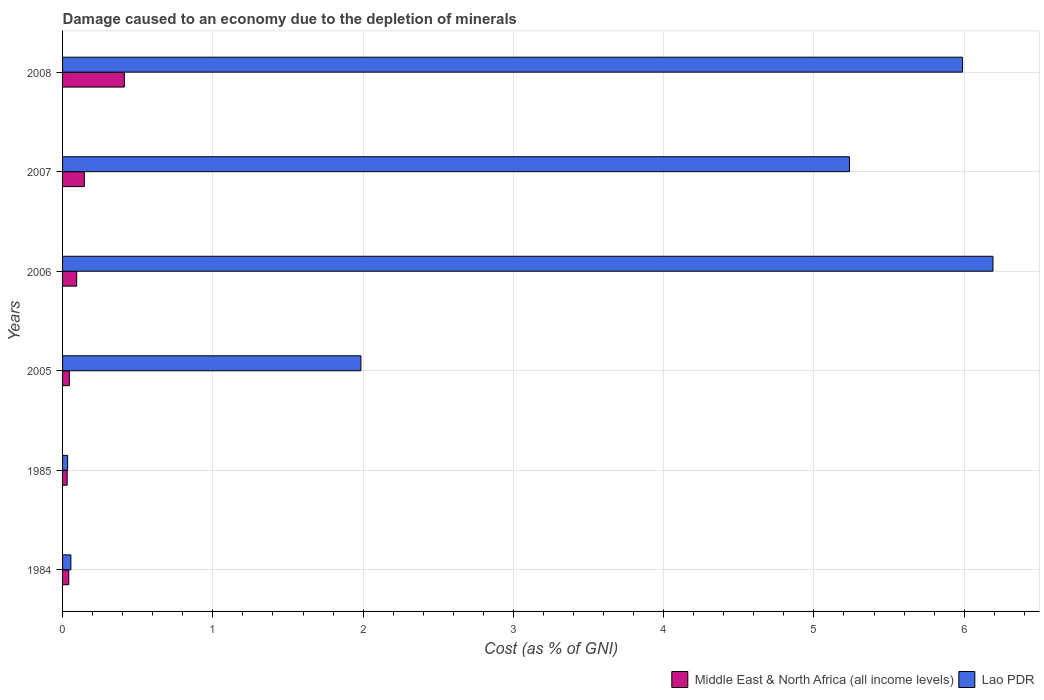What is the label of the 6th group of bars from the top?
Your response must be concise. 1984. What is the cost of damage caused due to the depletion of minerals in Lao PDR in 2006?
Your answer should be very brief. 6.19. Across all years, what is the maximum cost of damage caused due to the depletion of minerals in Middle East & North Africa (all income levels)?
Provide a short and direct response. 0.41. Across all years, what is the minimum cost of damage caused due to the depletion of minerals in Middle East & North Africa (all income levels)?
Your answer should be compact. 0.03. In which year was the cost of damage caused due to the depletion of minerals in Lao PDR maximum?
Ensure brevity in your answer.  2006. What is the total cost of damage caused due to the depletion of minerals in Lao PDR in the graph?
Offer a very short reply. 19.49. What is the difference between the cost of damage caused due to the depletion of minerals in Middle East & North Africa (all income levels) in 2006 and that in 2007?
Keep it short and to the point. -0.05. What is the difference between the cost of damage caused due to the depletion of minerals in Lao PDR in 1985 and the cost of damage caused due to the depletion of minerals in Middle East & North Africa (all income levels) in 2007?
Provide a succinct answer. -0.11. What is the average cost of damage caused due to the depletion of minerals in Middle East & North Africa (all income levels) per year?
Make the answer very short. 0.13. In the year 2005, what is the difference between the cost of damage caused due to the depletion of minerals in Lao PDR and cost of damage caused due to the depletion of minerals in Middle East & North Africa (all income levels)?
Offer a terse response. 1.94. In how many years, is the cost of damage caused due to the depletion of minerals in Lao PDR greater than 4.8 %?
Provide a short and direct response. 3. What is the ratio of the cost of damage caused due to the depletion of minerals in Lao PDR in 2005 to that in 2008?
Give a very brief answer. 0.33. Is the difference between the cost of damage caused due to the depletion of minerals in Lao PDR in 1984 and 2007 greater than the difference between the cost of damage caused due to the depletion of minerals in Middle East & North Africa (all income levels) in 1984 and 2007?
Provide a succinct answer. No. What is the difference between the highest and the second highest cost of damage caused due to the depletion of minerals in Lao PDR?
Ensure brevity in your answer.  0.2. What is the difference between the highest and the lowest cost of damage caused due to the depletion of minerals in Lao PDR?
Keep it short and to the point. 6.16. In how many years, is the cost of damage caused due to the depletion of minerals in Middle East & North Africa (all income levels) greater than the average cost of damage caused due to the depletion of minerals in Middle East & North Africa (all income levels) taken over all years?
Offer a terse response. 2. What does the 1st bar from the top in 2007 represents?
Ensure brevity in your answer.  Lao PDR. What does the 2nd bar from the bottom in 1984 represents?
Make the answer very short. Lao PDR. How many bars are there?
Offer a very short reply. 12. Does the graph contain any zero values?
Offer a very short reply. No. Does the graph contain grids?
Make the answer very short. Yes. Where does the legend appear in the graph?
Ensure brevity in your answer.  Bottom right. How are the legend labels stacked?
Make the answer very short. Horizontal. What is the title of the graph?
Ensure brevity in your answer.  Damage caused to an economy due to the depletion of minerals. What is the label or title of the X-axis?
Offer a terse response. Cost (as % of GNI). What is the Cost (as % of GNI) of Middle East & North Africa (all income levels) in 1984?
Keep it short and to the point. 0.04. What is the Cost (as % of GNI) of Lao PDR in 1984?
Make the answer very short. 0.06. What is the Cost (as % of GNI) of Middle East & North Africa (all income levels) in 1985?
Ensure brevity in your answer.  0.03. What is the Cost (as % of GNI) in Lao PDR in 1985?
Make the answer very short. 0.03. What is the Cost (as % of GNI) in Middle East & North Africa (all income levels) in 2005?
Your answer should be very brief. 0.05. What is the Cost (as % of GNI) of Lao PDR in 2005?
Your answer should be compact. 1.99. What is the Cost (as % of GNI) of Middle East & North Africa (all income levels) in 2006?
Ensure brevity in your answer.  0.09. What is the Cost (as % of GNI) of Lao PDR in 2006?
Provide a short and direct response. 6.19. What is the Cost (as % of GNI) in Middle East & North Africa (all income levels) in 2007?
Your response must be concise. 0.14. What is the Cost (as % of GNI) in Lao PDR in 2007?
Offer a very short reply. 5.24. What is the Cost (as % of GNI) in Middle East & North Africa (all income levels) in 2008?
Your answer should be compact. 0.41. What is the Cost (as % of GNI) of Lao PDR in 2008?
Provide a short and direct response. 5.99. Across all years, what is the maximum Cost (as % of GNI) in Middle East & North Africa (all income levels)?
Your answer should be very brief. 0.41. Across all years, what is the maximum Cost (as % of GNI) in Lao PDR?
Offer a very short reply. 6.19. Across all years, what is the minimum Cost (as % of GNI) of Middle East & North Africa (all income levels)?
Your response must be concise. 0.03. Across all years, what is the minimum Cost (as % of GNI) in Lao PDR?
Your response must be concise. 0.03. What is the total Cost (as % of GNI) in Middle East & North Africa (all income levels) in the graph?
Provide a succinct answer. 0.77. What is the total Cost (as % of GNI) in Lao PDR in the graph?
Give a very brief answer. 19.49. What is the difference between the Cost (as % of GNI) in Middle East & North Africa (all income levels) in 1984 and that in 1985?
Provide a succinct answer. 0.01. What is the difference between the Cost (as % of GNI) of Lao PDR in 1984 and that in 1985?
Provide a succinct answer. 0.02. What is the difference between the Cost (as % of GNI) of Middle East & North Africa (all income levels) in 1984 and that in 2005?
Offer a very short reply. -0. What is the difference between the Cost (as % of GNI) in Lao PDR in 1984 and that in 2005?
Provide a succinct answer. -1.93. What is the difference between the Cost (as % of GNI) of Middle East & North Africa (all income levels) in 1984 and that in 2006?
Keep it short and to the point. -0.05. What is the difference between the Cost (as % of GNI) in Lao PDR in 1984 and that in 2006?
Your answer should be very brief. -6.14. What is the difference between the Cost (as % of GNI) of Middle East & North Africa (all income levels) in 1984 and that in 2007?
Offer a very short reply. -0.1. What is the difference between the Cost (as % of GNI) in Lao PDR in 1984 and that in 2007?
Ensure brevity in your answer.  -5.18. What is the difference between the Cost (as % of GNI) of Middle East & North Africa (all income levels) in 1984 and that in 2008?
Provide a short and direct response. -0.37. What is the difference between the Cost (as % of GNI) in Lao PDR in 1984 and that in 2008?
Provide a short and direct response. -5.93. What is the difference between the Cost (as % of GNI) in Middle East & North Africa (all income levels) in 1985 and that in 2005?
Offer a terse response. -0.01. What is the difference between the Cost (as % of GNI) in Lao PDR in 1985 and that in 2005?
Offer a terse response. -1.95. What is the difference between the Cost (as % of GNI) of Middle East & North Africa (all income levels) in 1985 and that in 2006?
Provide a succinct answer. -0.06. What is the difference between the Cost (as % of GNI) of Lao PDR in 1985 and that in 2006?
Provide a short and direct response. -6.16. What is the difference between the Cost (as % of GNI) of Middle East & North Africa (all income levels) in 1985 and that in 2007?
Provide a succinct answer. -0.11. What is the difference between the Cost (as % of GNI) in Lao PDR in 1985 and that in 2007?
Ensure brevity in your answer.  -5.2. What is the difference between the Cost (as % of GNI) of Middle East & North Africa (all income levels) in 1985 and that in 2008?
Ensure brevity in your answer.  -0.38. What is the difference between the Cost (as % of GNI) in Lao PDR in 1985 and that in 2008?
Offer a very short reply. -5.96. What is the difference between the Cost (as % of GNI) of Middle East & North Africa (all income levels) in 2005 and that in 2006?
Offer a terse response. -0.05. What is the difference between the Cost (as % of GNI) in Lao PDR in 2005 and that in 2006?
Your answer should be very brief. -4.21. What is the difference between the Cost (as % of GNI) in Middle East & North Africa (all income levels) in 2005 and that in 2007?
Ensure brevity in your answer.  -0.1. What is the difference between the Cost (as % of GNI) of Lao PDR in 2005 and that in 2007?
Offer a terse response. -3.25. What is the difference between the Cost (as % of GNI) of Middle East & North Africa (all income levels) in 2005 and that in 2008?
Offer a terse response. -0.37. What is the difference between the Cost (as % of GNI) in Lao PDR in 2005 and that in 2008?
Provide a short and direct response. -4. What is the difference between the Cost (as % of GNI) in Middle East & North Africa (all income levels) in 2006 and that in 2007?
Your answer should be very brief. -0.05. What is the difference between the Cost (as % of GNI) of Lao PDR in 2006 and that in 2007?
Offer a very short reply. 0.95. What is the difference between the Cost (as % of GNI) in Middle East & North Africa (all income levels) in 2006 and that in 2008?
Offer a very short reply. -0.32. What is the difference between the Cost (as % of GNI) of Lao PDR in 2006 and that in 2008?
Ensure brevity in your answer.  0.2. What is the difference between the Cost (as % of GNI) of Middle East & North Africa (all income levels) in 2007 and that in 2008?
Your response must be concise. -0.27. What is the difference between the Cost (as % of GNI) in Lao PDR in 2007 and that in 2008?
Keep it short and to the point. -0.75. What is the difference between the Cost (as % of GNI) in Middle East & North Africa (all income levels) in 1984 and the Cost (as % of GNI) in Lao PDR in 1985?
Your answer should be very brief. 0.01. What is the difference between the Cost (as % of GNI) of Middle East & North Africa (all income levels) in 1984 and the Cost (as % of GNI) of Lao PDR in 2005?
Offer a very short reply. -1.94. What is the difference between the Cost (as % of GNI) of Middle East & North Africa (all income levels) in 1984 and the Cost (as % of GNI) of Lao PDR in 2006?
Your response must be concise. -6.15. What is the difference between the Cost (as % of GNI) in Middle East & North Africa (all income levels) in 1984 and the Cost (as % of GNI) in Lao PDR in 2007?
Your answer should be compact. -5.2. What is the difference between the Cost (as % of GNI) in Middle East & North Africa (all income levels) in 1984 and the Cost (as % of GNI) in Lao PDR in 2008?
Your answer should be compact. -5.95. What is the difference between the Cost (as % of GNI) of Middle East & North Africa (all income levels) in 1985 and the Cost (as % of GNI) of Lao PDR in 2005?
Provide a succinct answer. -1.95. What is the difference between the Cost (as % of GNI) in Middle East & North Africa (all income levels) in 1985 and the Cost (as % of GNI) in Lao PDR in 2006?
Make the answer very short. -6.16. What is the difference between the Cost (as % of GNI) in Middle East & North Africa (all income levels) in 1985 and the Cost (as % of GNI) in Lao PDR in 2007?
Your response must be concise. -5.21. What is the difference between the Cost (as % of GNI) in Middle East & North Africa (all income levels) in 1985 and the Cost (as % of GNI) in Lao PDR in 2008?
Your response must be concise. -5.96. What is the difference between the Cost (as % of GNI) in Middle East & North Africa (all income levels) in 2005 and the Cost (as % of GNI) in Lao PDR in 2006?
Make the answer very short. -6.15. What is the difference between the Cost (as % of GNI) of Middle East & North Africa (all income levels) in 2005 and the Cost (as % of GNI) of Lao PDR in 2007?
Make the answer very short. -5.19. What is the difference between the Cost (as % of GNI) in Middle East & North Africa (all income levels) in 2005 and the Cost (as % of GNI) in Lao PDR in 2008?
Your answer should be compact. -5.94. What is the difference between the Cost (as % of GNI) in Middle East & North Africa (all income levels) in 2006 and the Cost (as % of GNI) in Lao PDR in 2007?
Offer a terse response. -5.14. What is the difference between the Cost (as % of GNI) in Middle East & North Africa (all income levels) in 2006 and the Cost (as % of GNI) in Lao PDR in 2008?
Offer a terse response. -5.9. What is the difference between the Cost (as % of GNI) in Middle East & North Africa (all income levels) in 2007 and the Cost (as % of GNI) in Lao PDR in 2008?
Keep it short and to the point. -5.84. What is the average Cost (as % of GNI) of Middle East & North Africa (all income levels) per year?
Give a very brief answer. 0.13. What is the average Cost (as % of GNI) in Lao PDR per year?
Provide a short and direct response. 3.25. In the year 1984, what is the difference between the Cost (as % of GNI) in Middle East & North Africa (all income levels) and Cost (as % of GNI) in Lao PDR?
Provide a short and direct response. -0.01. In the year 1985, what is the difference between the Cost (as % of GNI) of Middle East & North Africa (all income levels) and Cost (as % of GNI) of Lao PDR?
Offer a very short reply. -0. In the year 2005, what is the difference between the Cost (as % of GNI) in Middle East & North Africa (all income levels) and Cost (as % of GNI) in Lao PDR?
Make the answer very short. -1.94. In the year 2006, what is the difference between the Cost (as % of GNI) of Middle East & North Africa (all income levels) and Cost (as % of GNI) of Lao PDR?
Your answer should be compact. -6.1. In the year 2007, what is the difference between the Cost (as % of GNI) in Middle East & North Africa (all income levels) and Cost (as % of GNI) in Lao PDR?
Give a very brief answer. -5.09. In the year 2008, what is the difference between the Cost (as % of GNI) in Middle East & North Africa (all income levels) and Cost (as % of GNI) in Lao PDR?
Your response must be concise. -5.58. What is the ratio of the Cost (as % of GNI) of Middle East & North Africa (all income levels) in 1984 to that in 1985?
Make the answer very short. 1.35. What is the ratio of the Cost (as % of GNI) of Lao PDR in 1984 to that in 1985?
Offer a very short reply. 1.64. What is the ratio of the Cost (as % of GNI) of Middle East & North Africa (all income levels) in 1984 to that in 2005?
Your response must be concise. 0.91. What is the ratio of the Cost (as % of GNI) in Lao PDR in 1984 to that in 2005?
Give a very brief answer. 0.03. What is the ratio of the Cost (as % of GNI) in Middle East & North Africa (all income levels) in 1984 to that in 2006?
Offer a terse response. 0.44. What is the ratio of the Cost (as % of GNI) in Lao PDR in 1984 to that in 2006?
Keep it short and to the point. 0.01. What is the ratio of the Cost (as % of GNI) of Middle East & North Africa (all income levels) in 1984 to that in 2007?
Offer a terse response. 0.29. What is the ratio of the Cost (as % of GNI) of Lao PDR in 1984 to that in 2007?
Provide a short and direct response. 0.01. What is the ratio of the Cost (as % of GNI) of Middle East & North Africa (all income levels) in 1984 to that in 2008?
Give a very brief answer. 0.1. What is the ratio of the Cost (as % of GNI) in Lao PDR in 1984 to that in 2008?
Provide a short and direct response. 0.01. What is the ratio of the Cost (as % of GNI) of Middle East & North Africa (all income levels) in 1985 to that in 2005?
Offer a very short reply. 0.68. What is the ratio of the Cost (as % of GNI) in Lao PDR in 1985 to that in 2005?
Offer a terse response. 0.02. What is the ratio of the Cost (as % of GNI) in Middle East & North Africa (all income levels) in 1985 to that in 2006?
Give a very brief answer. 0.33. What is the ratio of the Cost (as % of GNI) in Lao PDR in 1985 to that in 2006?
Offer a terse response. 0.01. What is the ratio of the Cost (as % of GNI) of Middle East & North Africa (all income levels) in 1985 to that in 2007?
Give a very brief answer. 0.21. What is the ratio of the Cost (as % of GNI) of Lao PDR in 1985 to that in 2007?
Your answer should be compact. 0.01. What is the ratio of the Cost (as % of GNI) in Middle East & North Africa (all income levels) in 1985 to that in 2008?
Ensure brevity in your answer.  0.07. What is the ratio of the Cost (as % of GNI) of Lao PDR in 1985 to that in 2008?
Give a very brief answer. 0.01. What is the ratio of the Cost (as % of GNI) of Middle East & North Africa (all income levels) in 2005 to that in 2006?
Offer a very short reply. 0.48. What is the ratio of the Cost (as % of GNI) of Lao PDR in 2005 to that in 2006?
Your answer should be compact. 0.32. What is the ratio of the Cost (as % of GNI) of Middle East & North Africa (all income levels) in 2005 to that in 2007?
Offer a very short reply. 0.31. What is the ratio of the Cost (as % of GNI) in Lao PDR in 2005 to that in 2007?
Offer a very short reply. 0.38. What is the ratio of the Cost (as % of GNI) in Middle East & North Africa (all income levels) in 2005 to that in 2008?
Your answer should be compact. 0.11. What is the ratio of the Cost (as % of GNI) of Lao PDR in 2005 to that in 2008?
Ensure brevity in your answer.  0.33. What is the ratio of the Cost (as % of GNI) of Middle East & North Africa (all income levels) in 2006 to that in 2007?
Provide a succinct answer. 0.65. What is the ratio of the Cost (as % of GNI) of Lao PDR in 2006 to that in 2007?
Your answer should be very brief. 1.18. What is the ratio of the Cost (as % of GNI) of Middle East & North Africa (all income levels) in 2006 to that in 2008?
Ensure brevity in your answer.  0.23. What is the ratio of the Cost (as % of GNI) of Lao PDR in 2006 to that in 2008?
Give a very brief answer. 1.03. What is the ratio of the Cost (as % of GNI) in Middle East & North Africa (all income levels) in 2007 to that in 2008?
Provide a succinct answer. 0.35. What is the ratio of the Cost (as % of GNI) of Lao PDR in 2007 to that in 2008?
Make the answer very short. 0.87. What is the difference between the highest and the second highest Cost (as % of GNI) of Middle East & North Africa (all income levels)?
Give a very brief answer. 0.27. What is the difference between the highest and the second highest Cost (as % of GNI) in Lao PDR?
Give a very brief answer. 0.2. What is the difference between the highest and the lowest Cost (as % of GNI) of Middle East & North Africa (all income levels)?
Ensure brevity in your answer.  0.38. What is the difference between the highest and the lowest Cost (as % of GNI) of Lao PDR?
Keep it short and to the point. 6.16. 